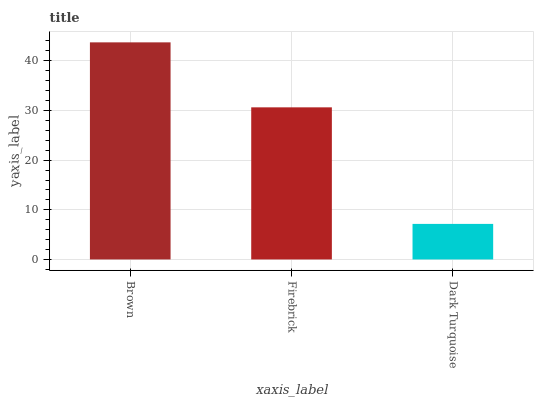Is Dark Turquoise the minimum?
Answer yes or no. Yes. Is Brown the maximum?
Answer yes or no. Yes. Is Firebrick the minimum?
Answer yes or no. No. Is Firebrick the maximum?
Answer yes or no. No. Is Brown greater than Firebrick?
Answer yes or no. Yes. Is Firebrick less than Brown?
Answer yes or no. Yes. Is Firebrick greater than Brown?
Answer yes or no. No. Is Brown less than Firebrick?
Answer yes or no. No. Is Firebrick the high median?
Answer yes or no. Yes. Is Firebrick the low median?
Answer yes or no. Yes. Is Dark Turquoise the high median?
Answer yes or no. No. Is Dark Turquoise the low median?
Answer yes or no. No. 